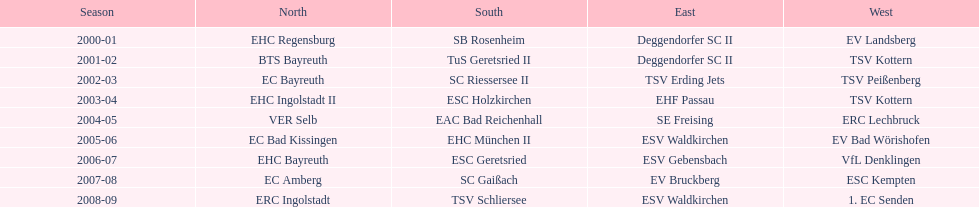Who emerged victorious in the south following esc geretsried's performance in the 2006-07 season? SC Gaißach. 